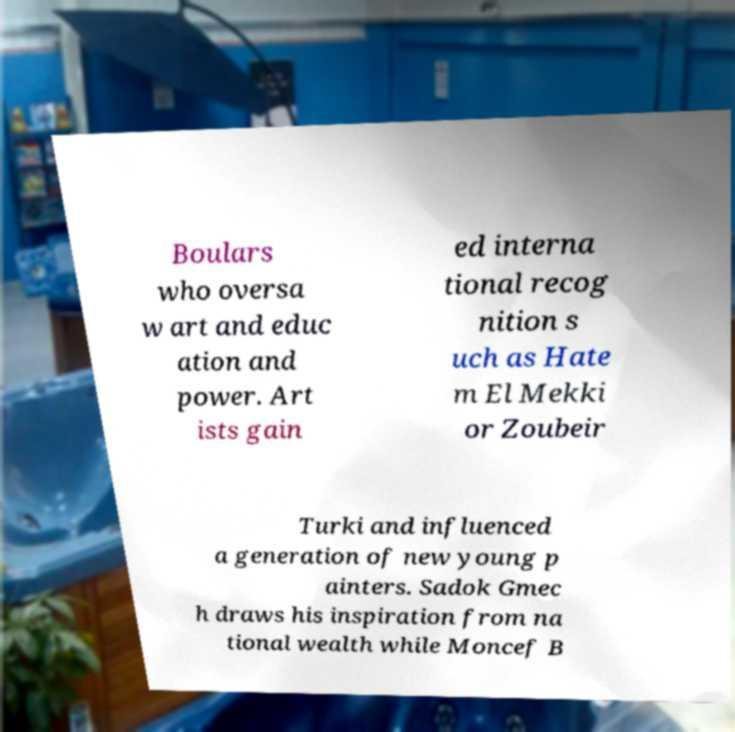What messages or text are displayed in this image? I need them in a readable, typed format. Boulars who oversa w art and educ ation and power. Art ists gain ed interna tional recog nition s uch as Hate m El Mekki or Zoubeir Turki and influenced a generation of new young p ainters. Sadok Gmec h draws his inspiration from na tional wealth while Moncef B 